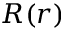Convert formula to latex. <formula><loc_0><loc_0><loc_500><loc_500>R ( r )</formula> 